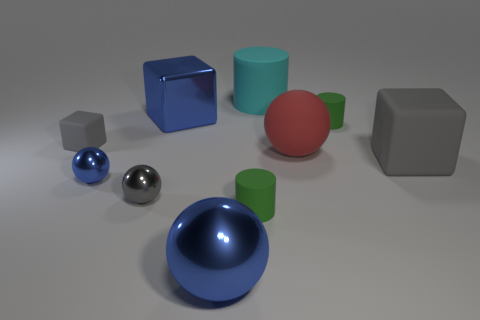Subtract all gray cubes. How many cubes are left? 1 Subtract all cyan cylinders. How many cylinders are left? 2 Subtract all cubes. How many objects are left? 7 Subtract 4 balls. How many balls are left? 0 Subtract all cyan cylinders. How many red cubes are left? 0 Subtract 0 yellow balls. How many objects are left? 10 Subtract all purple cylinders. Subtract all gray blocks. How many cylinders are left? 3 Subtract all gray blocks. Subtract all big matte things. How many objects are left? 5 Add 7 large matte balls. How many large matte balls are left? 8 Add 7 large matte cylinders. How many large matte cylinders exist? 8 